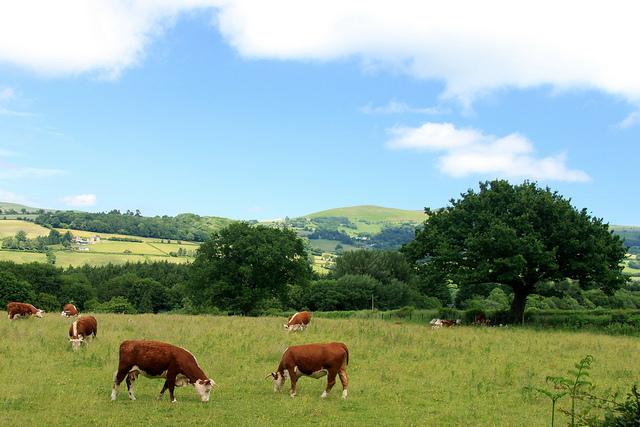How many cows appear to be eating?
Keep it brief. 6. What colors are the cows?
Write a very short answer. Brown and white. How many cows are in the picture?
Answer briefly. 6. How many cows are away from the group?
Keep it brief. 2. Where are the cows grazing in this photo?
Short answer required. Field. What are the cows doing in this photo?
Short answer required. Grazing. 